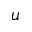Convert formula to latex. <formula><loc_0><loc_0><loc_500><loc_500>u</formula> 